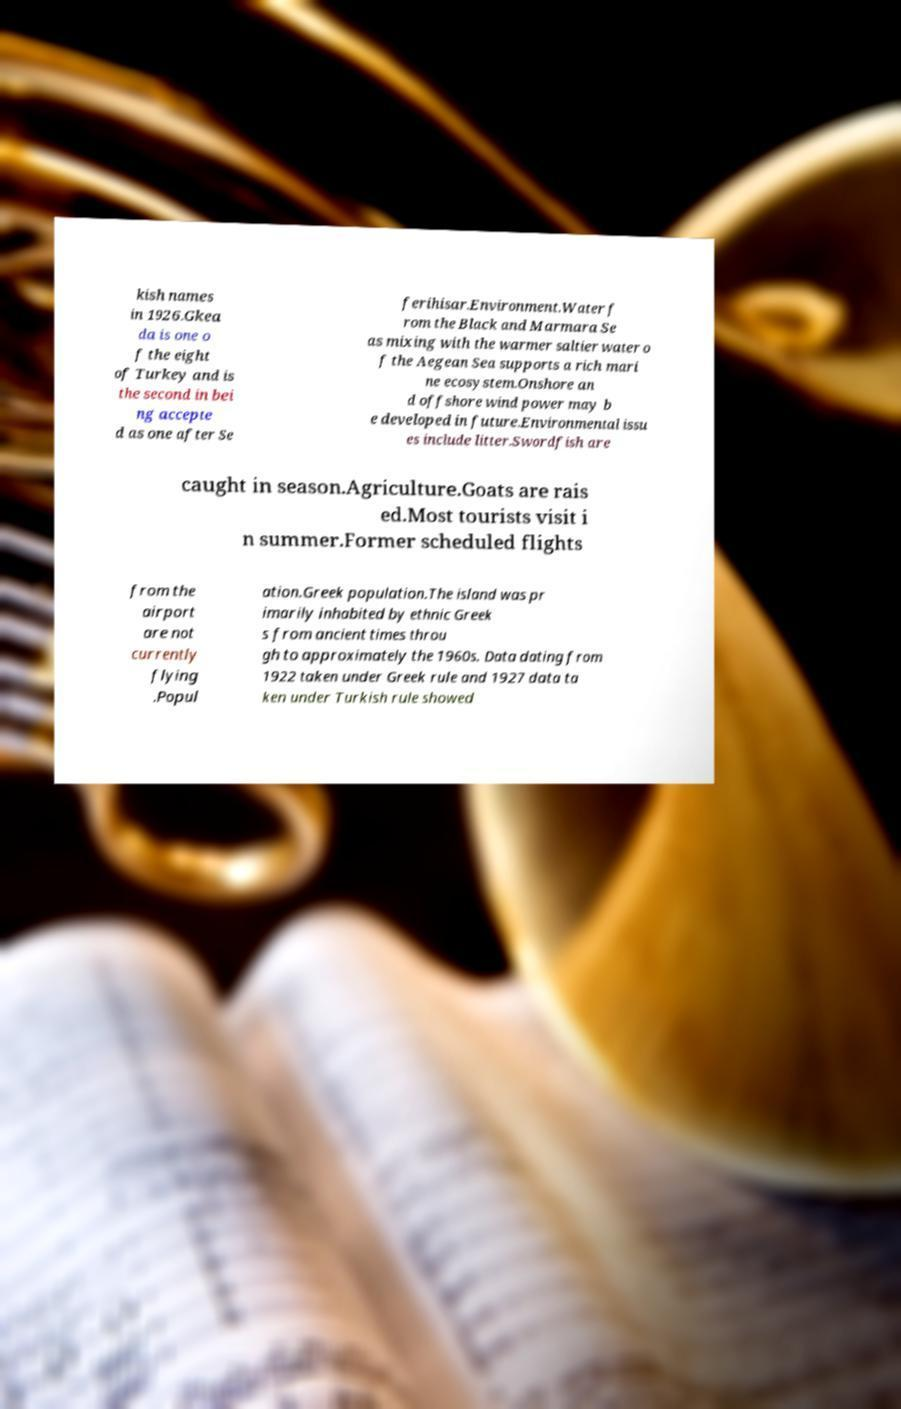There's text embedded in this image that I need extracted. Can you transcribe it verbatim? kish names in 1926.Gkea da is one o f the eight of Turkey and is the second in bei ng accepte d as one after Se ferihisar.Environment.Water f rom the Black and Marmara Se as mixing with the warmer saltier water o f the Aegean Sea supports a rich mari ne ecosystem.Onshore an d offshore wind power may b e developed in future.Environmental issu es include litter.Swordfish are caught in season.Agriculture.Goats are rais ed.Most tourists visit i n summer.Former scheduled flights from the airport are not currently flying .Popul ation.Greek population.The island was pr imarily inhabited by ethnic Greek s from ancient times throu gh to approximately the 1960s. Data dating from 1922 taken under Greek rule and 1927 data ta ken under Turkish rule showed 